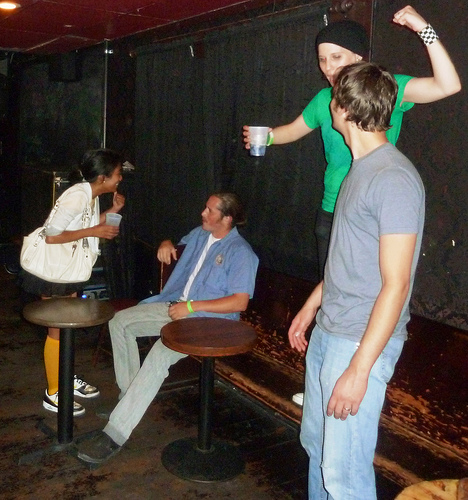<image>
Can you confirm if the man is to the left of the woman? No. The man is not to the left of the woman. From this viewpoint, they have a different horizontal relationship. 